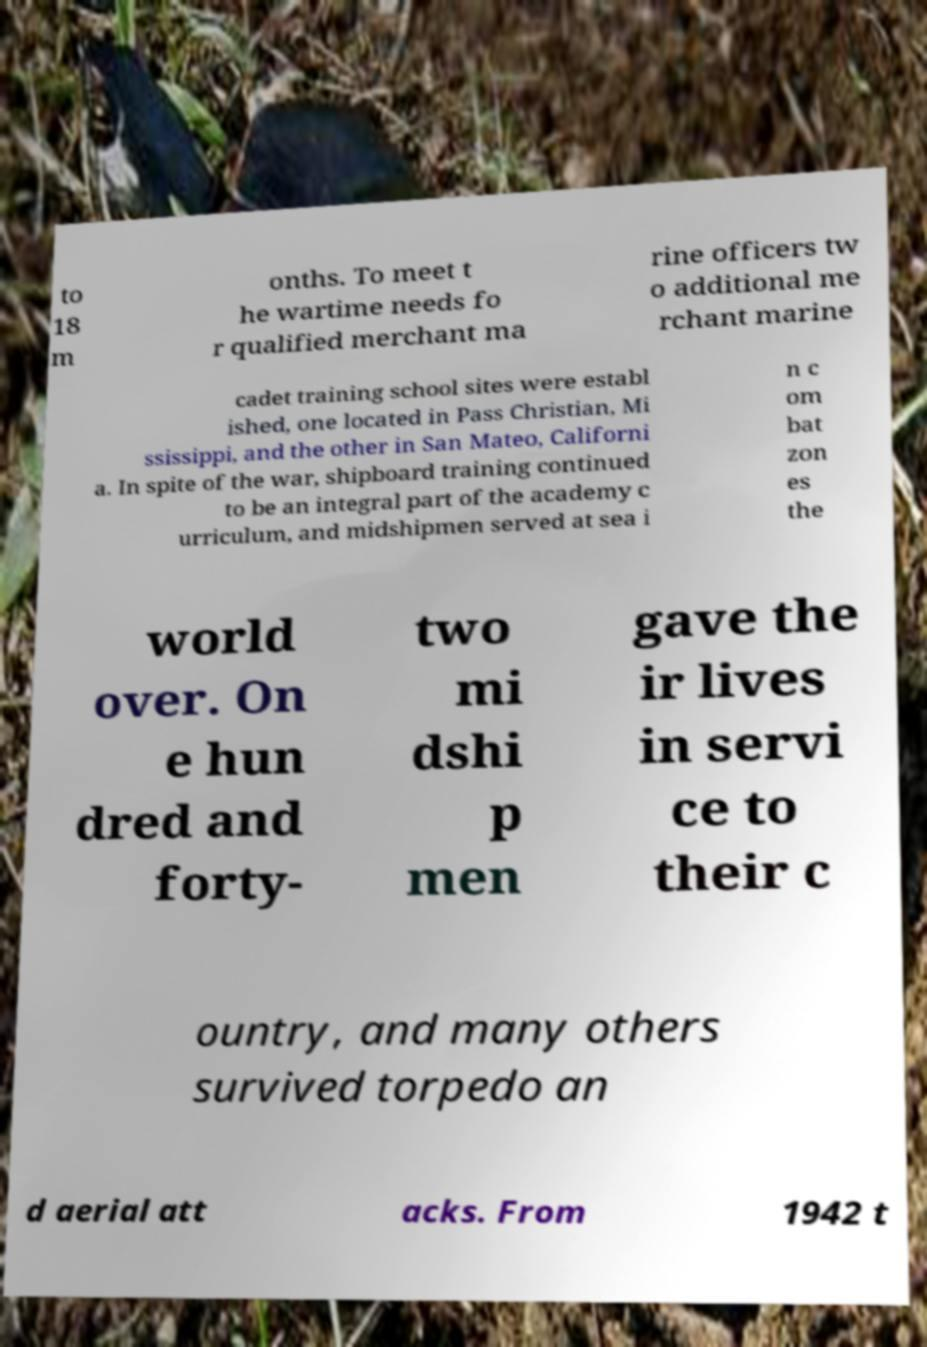There's text embedded in this image that I need extracted. Can you transcribe it verbatim? to 18 m onths. To meet t he wartime needs fo r qualified merchant ma rine officers tw o additional me rchant marine cadet training school sites were establ ished, one located in Pass Christian, Mi ssissippi, and the other in San Mateo, Californi a. In spite of the war, shipboard training continued to be an integral part of the academy c urriculum, and midshipmen served at sea i n c om bat zon es the world over. On e hun dred and forty- two mi dshi p men gave the ir lives in servi ce to their c ountry, and many others survived torpedo an d aerial att acks. From 1942 t 